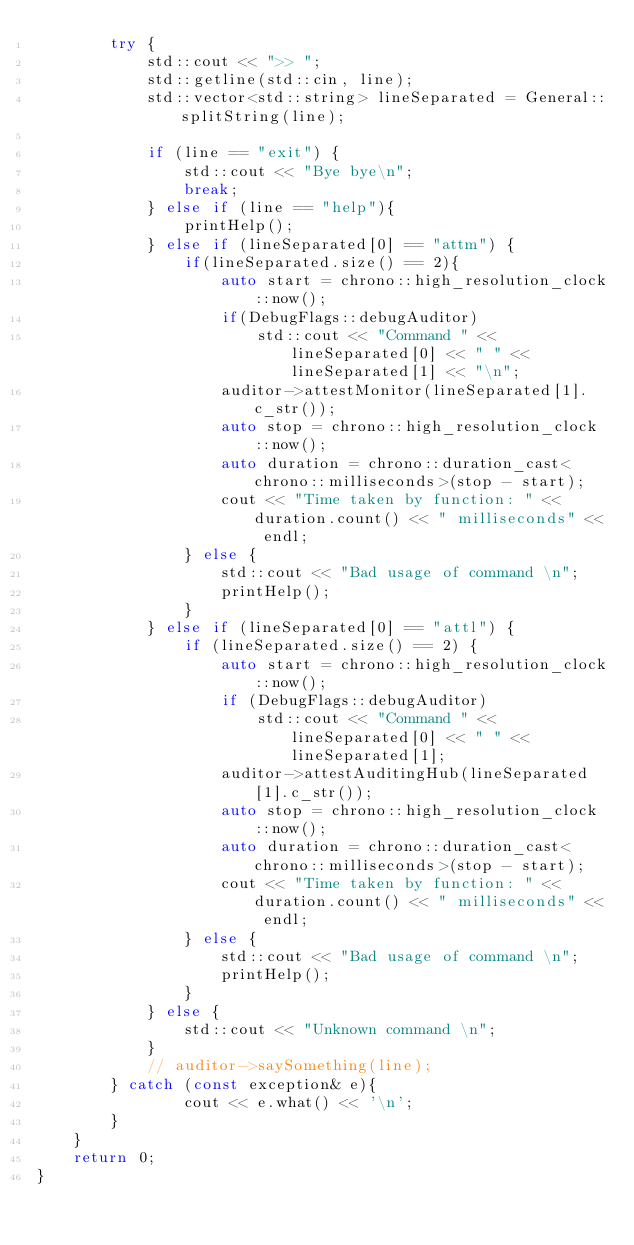Convert code to text. <code><loc_0><loc_0><loc_500><loc_500><_C++_>        try {
            std::cout << ">> ";
            std::getline(std::cin, line);
            std::vector<std::string> lineSeparated = General::splitString(line);

            if (line == "exit") {
                std::cout << "Bye bye\n";
                break;
            } else if (line == "help"){
                printHelp();
            } else if (lineSeparated[0] == "attm") {
                if(lineSeparated.size() == 2){
                    auto start = chrono::high_resolution_clock::now(); 
                    if(DebugFlags::debugAuditor)
                        std::cout << "Command " << lineSeparated[0] << " " << lineSeparated[1] << "\n";
                    auditor->attestMonitor(lineSeparated[1].c_str());
                    auto stop = chrono::high_resolution_clock::now(); 
                    auto duration = chrono::duration_cast<chrono::milliseconds>(stop - start); 
                    cout << "Time taken by function: " << duration.count() << " milliseconds" << endl;
                } else {
                    std::cout << "Bad usage of command \n";
                    printHelp();
                }
            } else if (lineSeparated[0] == "attl") {
                if (lineSeparated.size() == 2) {
                    auto start = chrono::high_resolution_clock::now(); 
                    if (DebugFlags::debugAuditor)
                        std::cout << "Command " << lineSeparated[0] << " " << lineSeparated[1];
                    auditor->attestAuditingHub(lineSeparated[1].c_str());
                    auto stop = chrono::high_resolution_clock::now(); 
                    auto duration = chrono::duration_cast<chrono::milliseconds>(stop - start); 
                    cout << "Time taken by function: " << duration.count() << " milliseconds" << endl;
                } else {
                    std::cout << "Bad usage of command \n";
                    printHelp();
                }
            } else {
                std::cout << "Unknown command \n";
            }
            // auditor->saySomething(line);
        } catch (const exception& e){
                cout << e.what() << '\n';
        }
    }
    return 0;
}
</code> 